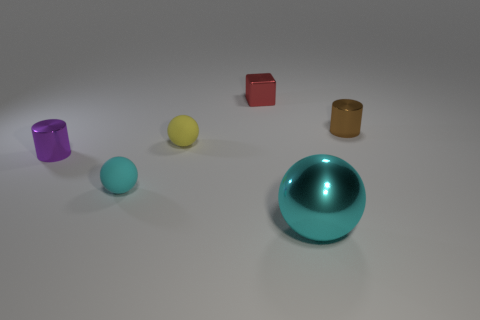Add 1 red shiny things. How many objects exist? 7 Subtract all blocks. How many objects are left? 5 Add 6 tiny cyan rubber objects. How many tiny cyan rubber objects exist? 7 Subtract 0 cyan blocks. How many objects are left? 6 Subtract all small cyan matte spheres. Subtract all blue metallic cubes. How many objects are left? 5 Add 6 cyan matte balls. How many cyan matte balls are left? 7 